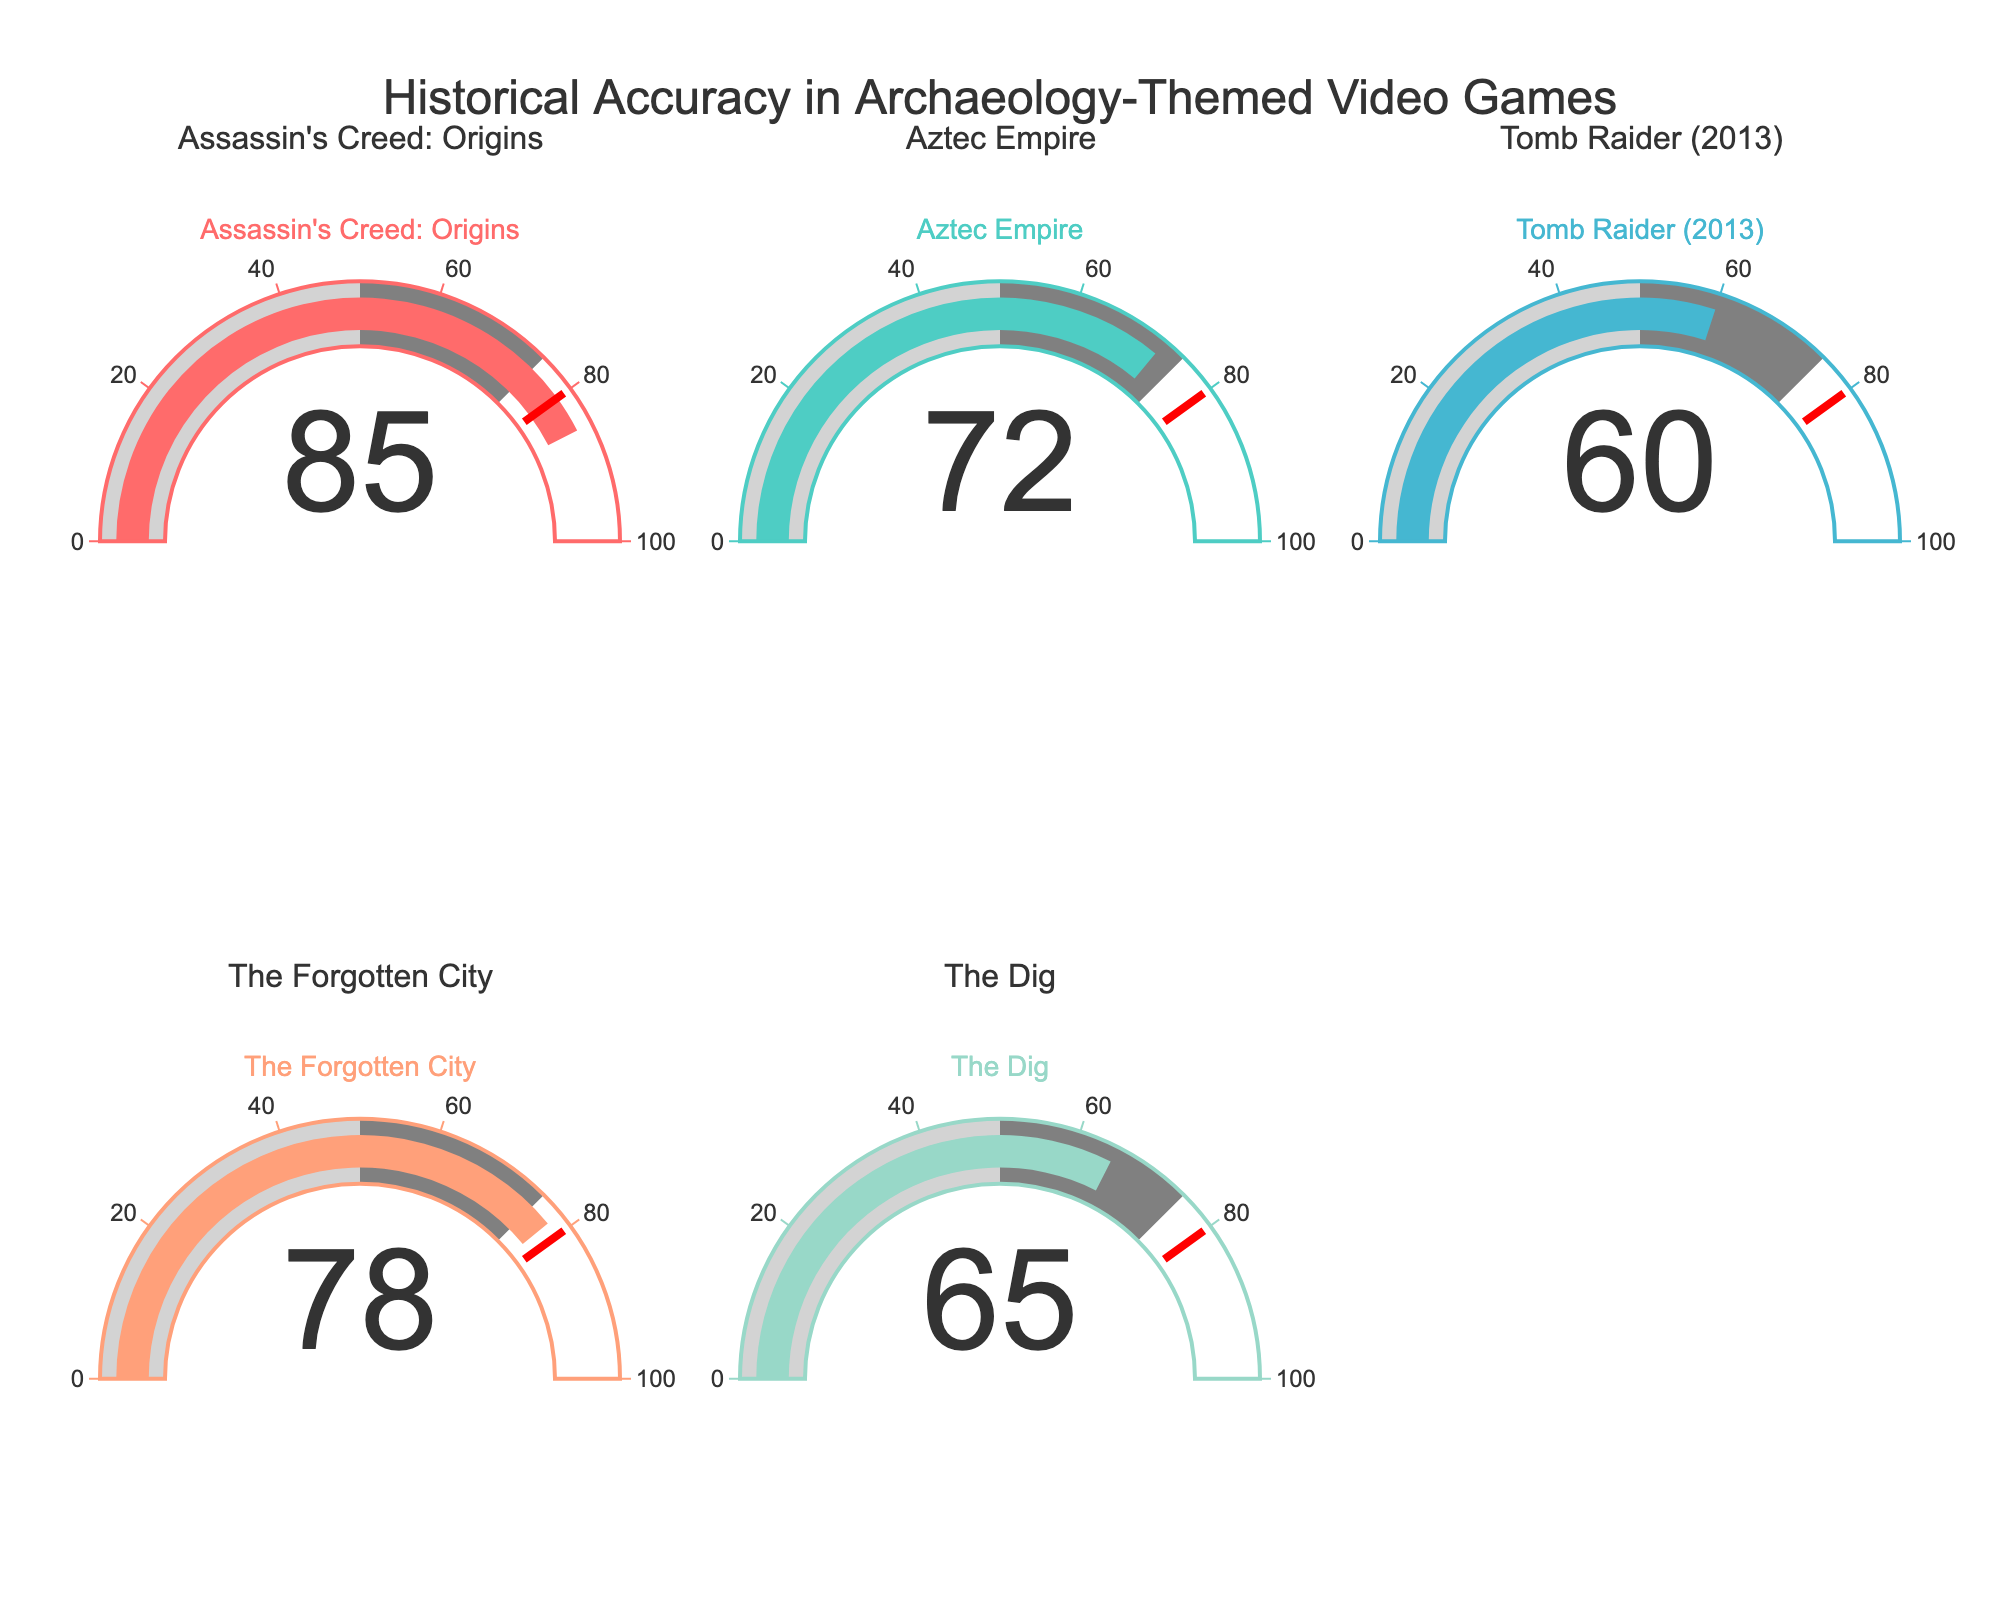What's the title of the figure? The title is displayed at the top center of the figure, reading "Historical Accuracy in Archaeology-Themed Video Games".
Answer: Historical Accuracy in Archaeology-Themed Video Games How many games are analyzed in the figure? Each gauge represents a distinct video game, and there are 5 gauges, one for each game.
Answer: 5 Which game has the highest accuracy percentage? By observing the numbers displayed on each gauge, the game "Assassin's Creed: Origins" has the highest value at 85.
Answer: Assassin's Creed: Origins What is the accuracy percentage of "The Forgotten City”? The gauge for "The Forgotten City" displays the value 78.
Answer: 78 Which game has a lower accuracy percentage, "Tomb Raider (2013)" or "The Dig"? Comparing the values on the gauges, "Tomb Raider (2013)" has an accuracy of 60, while "The Dig" has an accuracy of 65. Thus, "Tomb Raider (2013)" has a lower percentage.
Answer: Tomb Raider (2013) What is the average accuracy percentage across all games? Summing the accuracy percentages: 85 (Assassin's Creed: Origins) + 72 (Aztec Empire) + 60 (Tomb Raider (2013)) + 78 (The Forgotten City) + 65 (The Dig) = 360. Dividing by the number of games, 360 / 5 = 72.
Answer: 72 Which games have an accuracy percentage greater than 70? Looking at the gauges, the games "Assassin's Creed: Origins" (85), "Aztec Empire" (72), and "The Forgotten City" (78) all have percentages greater than 70.
Answer: Assassin's Creed: Origins, Aztec Empire, The Forgotten City Is there any game with an accuracy percentage below 65? The gauge for "Tomb Raider (2013)" shows 60, which is below 65.
Answer: Yes What is the difference in accuracy percentage between the game with the highest and the game with the lowest accuracy? The highest accuracy percentage is 85 for "Assassin's Creed: Origins", and the lowest is 60 for "Tomb Raider (2013)". The difference is 85 - 60 = 25.
Answer: 25 How many games have an accuracy percentage between 60 and 80? The gauges for "Aztec Empire" (72), "The Forgotten City" (78), and "The Dig" (65) fall within this range, making 3 games in total.
Answer: 3 